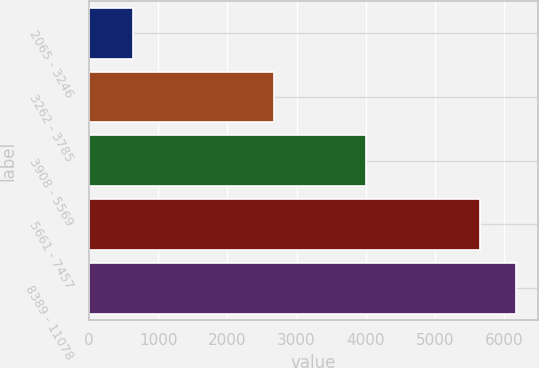Convert chart. <chart><loc_0><loc_0><loc_500><loc_500><bar_chart><fcel>2065 - 3246<fcel>3262 - 3785<fcel>3908 - 5569<fcel>5661 - 7457<fcel>8389 - 11078<nl><fcel>631<fcel>2670<fcel>4003<fcel>5645<fcel>6173.2<nl></chart> 